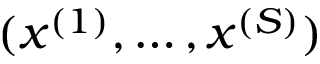<formula> <loc_0><loc_0><loc_500><loc_500>( x ^ { ( 1 ) } , \dots , x ^ { ( S ) } )</formula> 